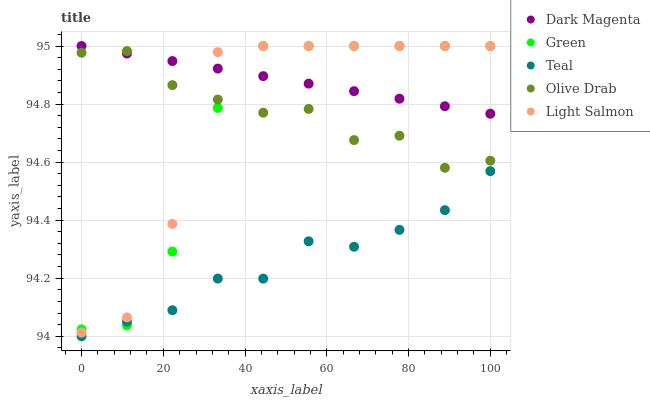Does Teal have the minimum area under the curve?
Answer yes or no. Yes. Does Dark Magenta have the maximum area under the curve?
Answer yes or no. Yes. Does Light Salmon have the minimum area under the curve?
Answer yes or no. No. Does Light Salmon have the maximum area under the curve?
Answer yes or no. No. Is Dark Magenta the smoothest?
Answer yes or no. Yes. Is Light Salmon the roughest?
Answer yes or no. Yes. Is Green the smoothest?
Answer yes or no. No. Is Green the roughest?
Answer yes or no. No. Does Teal have the lowest value?
Answer yes or no. Yes. Does Light Salmon have the lowest value?
Answer yes or no. No. Does Dark Magenta have the highest value?
Answer yes or no. Yes. Does Teal have the highest value?
Answer yes or no. No. Is Teal less than Light Salmon?
Answer yes or no. Yes. Is Olive Drab greater than Teal?
Answer yes or no. Yes. Does Teal intersect Green?
Answer yes or no. Yes. Is Teal less than Green?
Answer yes or no. No. Is Teal greater than Green?
Answer yes or no. No. Does Teal intersect Light Salmon?
Answer yes or no. No. 